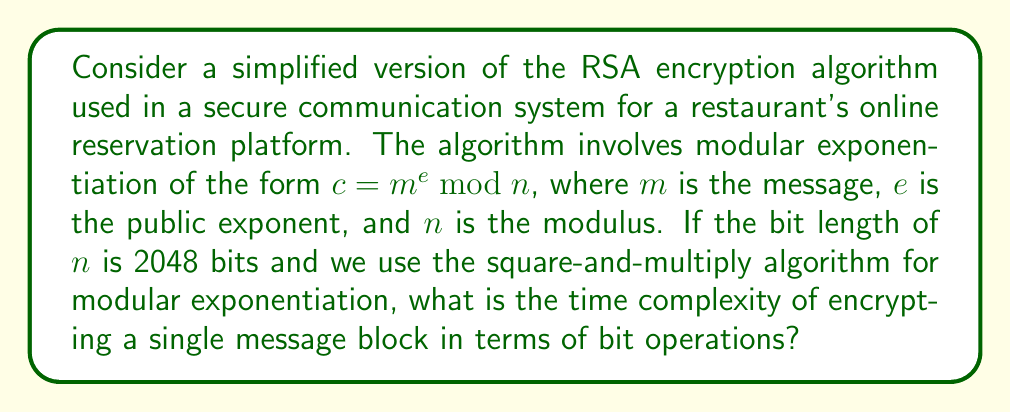Solve this math problem. Let's break this down step-by-step:

1) The RSA encryption operation is $c = m^e \bmod n$.

2) We're using the square-and-multiply algorithm for modular exponentiation. This algorithm works by scanning the bits of the exponent from left to right.

3) For each bit of the exponent:
   - We always perform a squaring operation
   - If the bit is 1, we also perform a multiplication

4) The number of squaring operations is equal to the number of bits in the exponent. In the worst case (when $e$ is close to $n$), this is equal to the bit length of $n$, which is 2048.

5) The number of multiplications depends on the number of 1's in the binary representation of $e$. In the worst case, this could also be up to 2048.

6) Each squaring or multiplication operation involves operating on numbers with up to 2048 bits.

7) A single multiplication or squaring of two 2048-bit numbers using the schoolbook method has a time complexity of $O(2048^2) = O(n^2)$ bit operations, where $n$ is the bit length of the modulus.

8) We perform up to 2048 such operations (in the worst case).

9) Therefore, the total time complexity is:

   $$O(2048 \cdot 2048^2) = O(2048^3) = O(n^3)$$

   where $n$ is the bit length of the modulus.

This cubic time complexity in terms of the bit length of the modulus is characteristic of the basic RSA algorithm using the square-and-multiply method for exponentiation.
Answer: $O(n^3)$, where $n$ is the bit length of the modulus. 